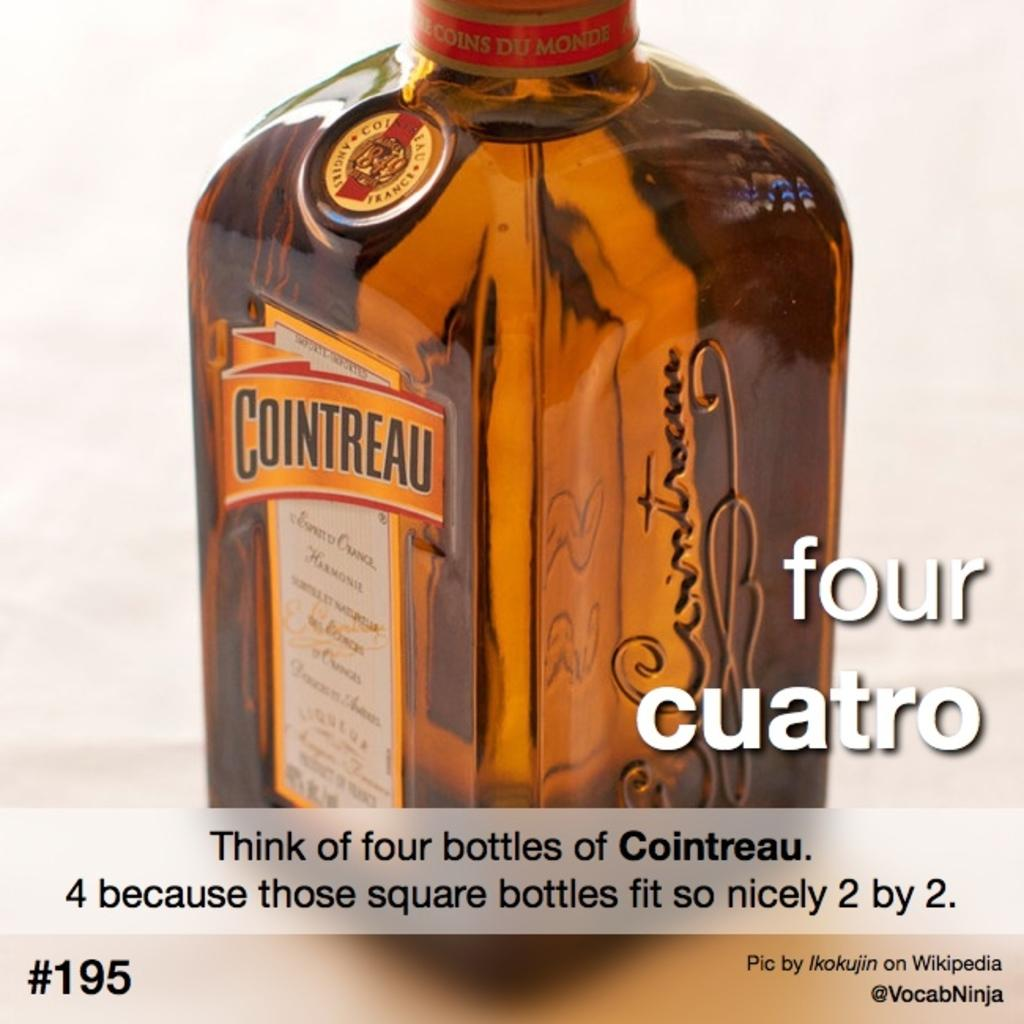Provide a one-sentence caption for the provided image. A bottle of orange flavored Cointreau liquor sits on a table. 